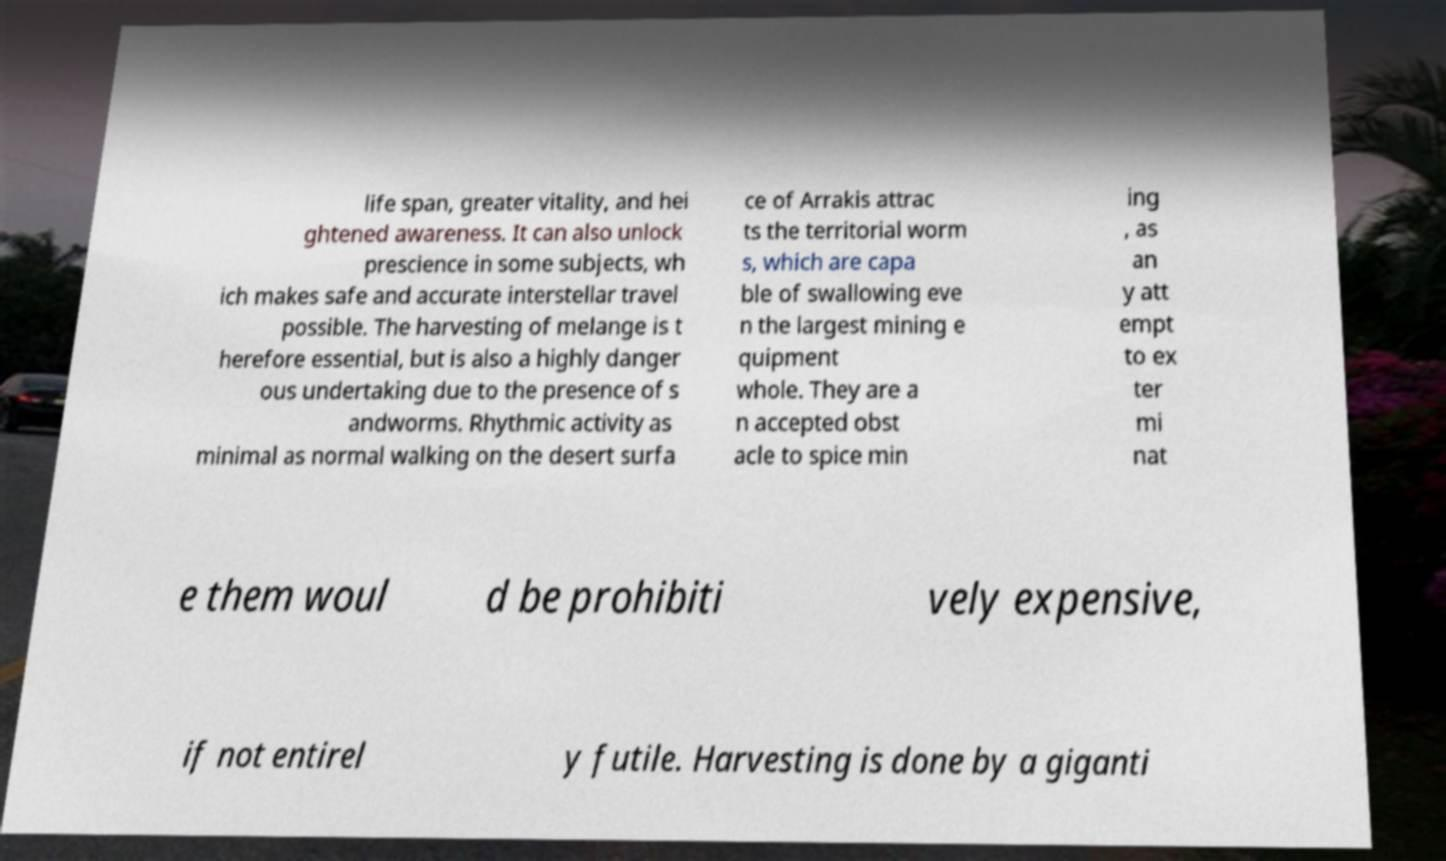Can you accurately transcribe the text from the provided image for me? life span, greater vitality, and hei ghtened awareness. It can also unlock prescience in some subjects, wh ich makes safe and accurate interstellar travel possible. The harvesting of melange is t herefore essential, but is also a highly danger ous undertaking due to the presence of s andworms. Rhythmic activity as minimal as normal walking on the desert surfa ce of Arrakis attrac ts the territorial worm s, which are capa ble of swallowing eve n the largest mining e quipment whole. They are a n accepted obst acle to spice min ing , as an y att empt to ex ter mi nat e them woul d be prohibiti vely expensive, if not entirel y futile. Harvesting is done by a giganti 